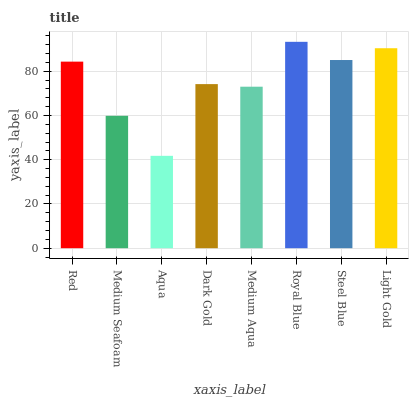Is Aqua the minimum?
Answer yes or no. Yes. Is Royal Blue the maximum?
Answer yes or no. Yes. Is Medium Seafoam the minimum?
Answer yes or no. No. Is Medium Seafoam the maximum?
Answer yes or no. No. Is Red greater than Medium Seafoam?
Answer yes or no. Yes. Is Medium Seafoam less than Red?
Answer yes or no. Yes. Is Medium Seafoam greater than Red?
Answer yes or no. No. Is Red less than Medium Seafoam?
Answer yes or no. No. Is Red the high median?
Answer yes or no. Yes. Is Dark Gold the low median?
Answer yes or no. Yes. Is Aqua the high median?
Answer yes or no. No. Is Steel Blue the low median?
Answer yes or no. No. 